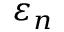Convert formula to latex. <formula><loc_0><loc_0><loc_500><loc_500>\varepsilon _ { n }</formula> 